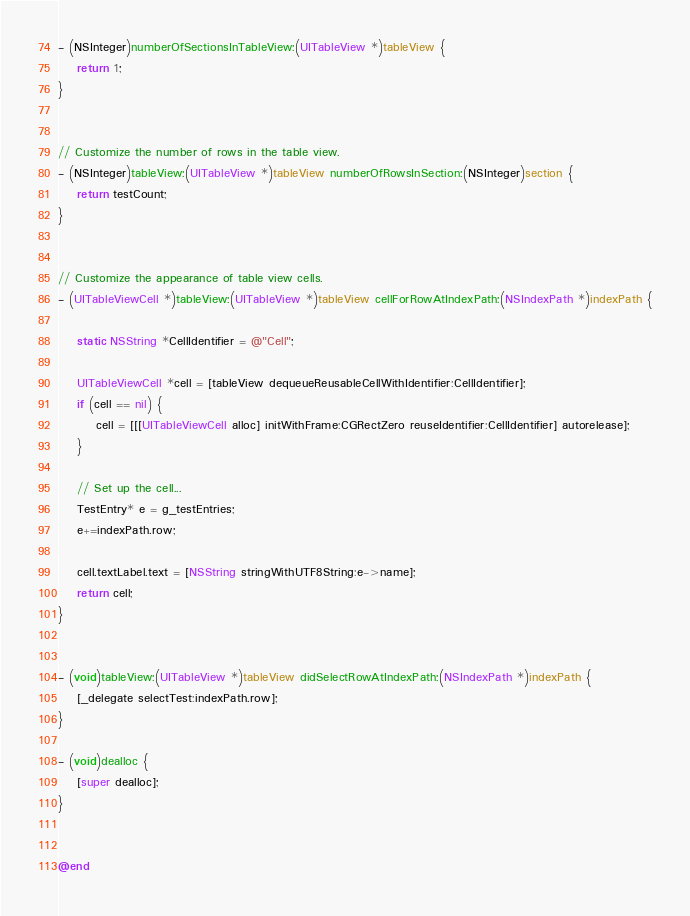<code> <loc_0><loc_0><loc_500><loc_500><_ObjectiveC_>
- (NSInteger)numberOfSectionsInTableView:(UITableView *)tableView {
    return 1;
}


// Customize the number of rows in the table view.
- (NSInteger)tableView:(UITableView *)tableView numberOfRowsInSection:(NSInteger)section {
    return testCount;
}


// Customize the appearance of table view cells.
- (UITableViewCell *)tableView:(UITableView *)tableView cellForRowAtIndexPath:(NSIndexPath *)indexPath {
    
    static NSString *CellIdentifier = @"Cell";
    
    UITableViewCell *cell = [tableView dequeueReusableCellWithIdentifier:CellIdentifier];
    if (cell == nil) {
        cell = [[[UITableViewCell alloc] initWithFrame:CGRectZero reuseIdentifier:CellIdentifier] autorelease];
    }
    
    // Set up the cell...
	TestEntry* e = g_testEntries;
	e+=indexPath.row;

	cell.textLabel.text = [NSString stringWithUTF8String:e->name];
    return cell;
}


- (void)tableView:(UITableView *)tableView didSelectRowAtIndexPath:(NSIndexPath *)indexPath {
	[_delegate selectTest:indexPath.row];
}

- (void)dealloc {
    [super dealloc];
}


@end

</code> 